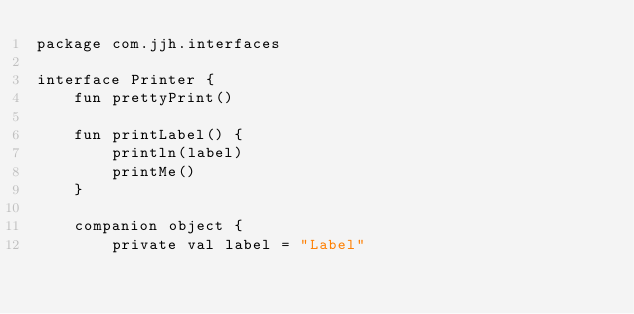Convert code to text. <code><loc_0><loc_0><loc_500><loc_500><_Kotlin_>package com.jjh.interfaces

interface Printer {
    fun prettyPrint()

    fun printLabel() {
        println(label)
        printMe()
    }

    companion object {
        private val label = "Label"</code> 